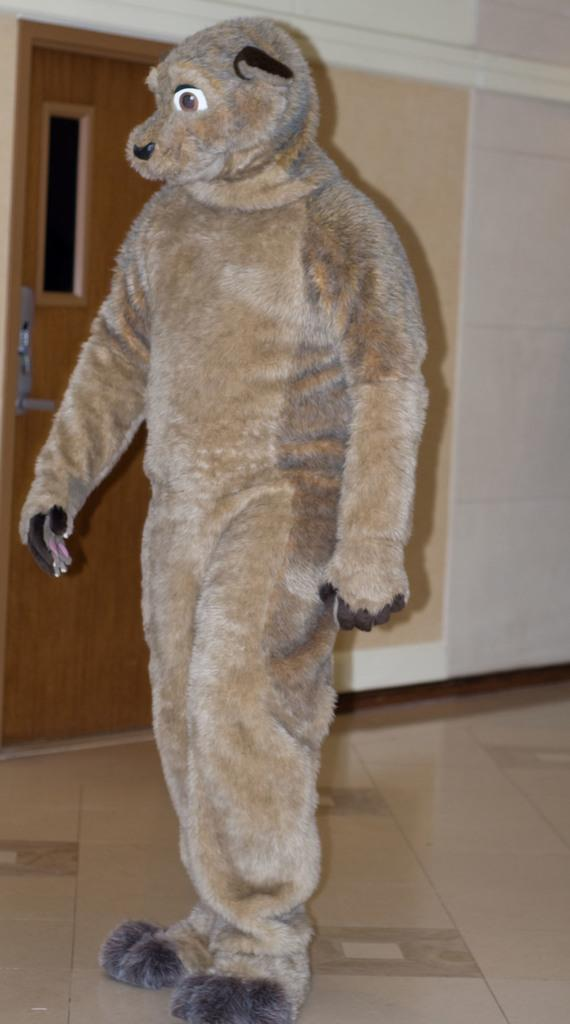What is the person in the image wearing? The person in the image is wearing a costume. What can be seen in the background of the image? There is a door and a wall visible in the background of the image. What is the surface on which the person is standing? There is a floor visible in the image. How many icicles are hanging from the costume in the image? There are no icicles present in the image; the person is wearing a costume. What is the title of the book the person is holding in the image? There is no book visible in the image, so it is not possible to determine the title. 